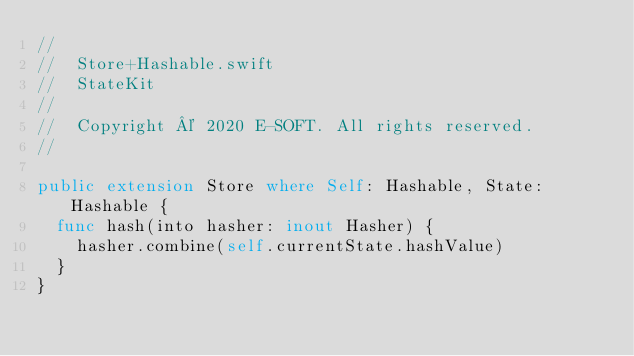Convert code to text. <code><loc_0><loc_0><loc_500><loc_500><_Swift_>//
//  Store+Hashable.swift
//  StateKit
//
//  Copyright © 2020 E-SOFT. All rights reserved.
//

public extension Store where Self: Hashable, State: Hashable {
  func hash(into hasher: inout Hasher) {
    hasher.combine(self.currentState.hashValue)
  }
}
</code> 